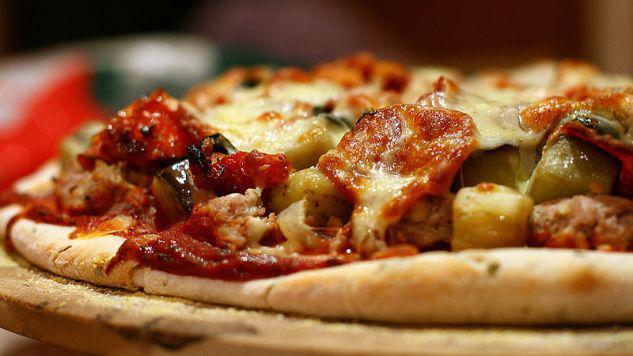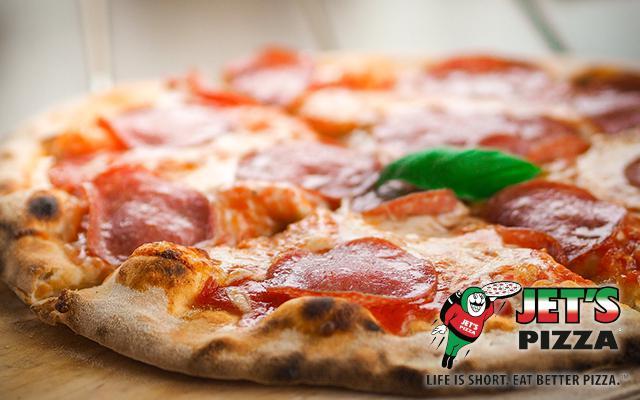The first image is the image on the left, the second image is the image on the right. Given the left and right images, does the statement "One of the pizzas is a cheese and pepperoni pizza." hold true? Answer yes or no. Yes. The first image is the image on the left, the second image is the image on the right. Given the left and right images, does the statement "There is at least one [basil] leaf on the pizza on the right." hold true? Answer yes or no. Yes. 